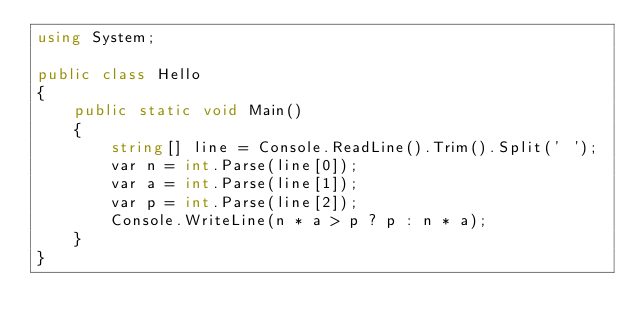Convert code to text. <code><loc_0><loc_0><loc_500><loc_500><_C#_>using System;

public class Hello
{
    public static void Main()
    {
        string[] line = Console.ReadLine().Trim().Split(' ');
        var n = int.Parse(line[0]);
        var a = int.Parse(line[1]);
        var p = int.Parse(line[2]);
        Console.WriteLine(n * a > p ? p : n * a);
    }
}
</code> 